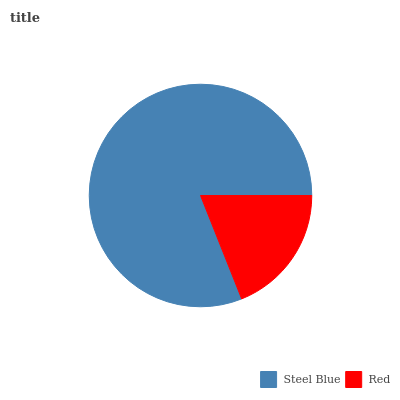Is Red the minimum?
Answer yes or no. Yes. Is Steel Blue the maximum?
Answer yes or no. Yes. Is Red the maximum?
Answer yes or no. No. Is Steel Blue greater than Red?
Answer yes or no. Yes. Is Red less than Steel Blue?
Answer yes or no. Yes. Is Red greater than Steel Blue?
Answer yes or no. No. Is Steel Blue less than Red?
Answer yes or no. No. Is Steel Blue the high median?
Answer yes or no. Yes. Is Red the low median?
Answer yes or no. Yes. Is Red the high median?
Answer yes or no. No. Is Steel Blue the low median?
Answer yes or no. No. 